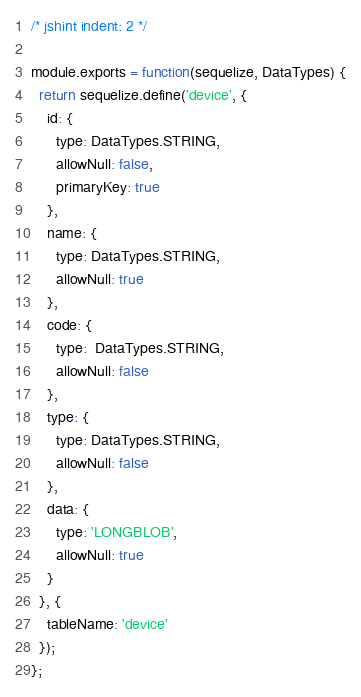Convert code to text. <code><loc_0><loc_0><loc_500><loc_500><_JavaScript_>/* jshint indent: 2 */

module.exports = function(sequelize, DataTypes) {
  return sequelize.define('device', {
    id: {
      type: DataTypes.STRING,
      allowNull: false,
      primaryKey: true
    },
    name: {
      type: DataTypes.STRING,
      allowNull: true
    },
    code: {
      type:  DataTypes.STRING,
      allowNull: false
    },
    type: {
      type: DataTypes.STRING,
      allowNull: false
    },
    data: {
      type: 'LONGBLOB',
      allowNull: true
    }
  }, {
    tableName: 'device'
  });
};
</code> 